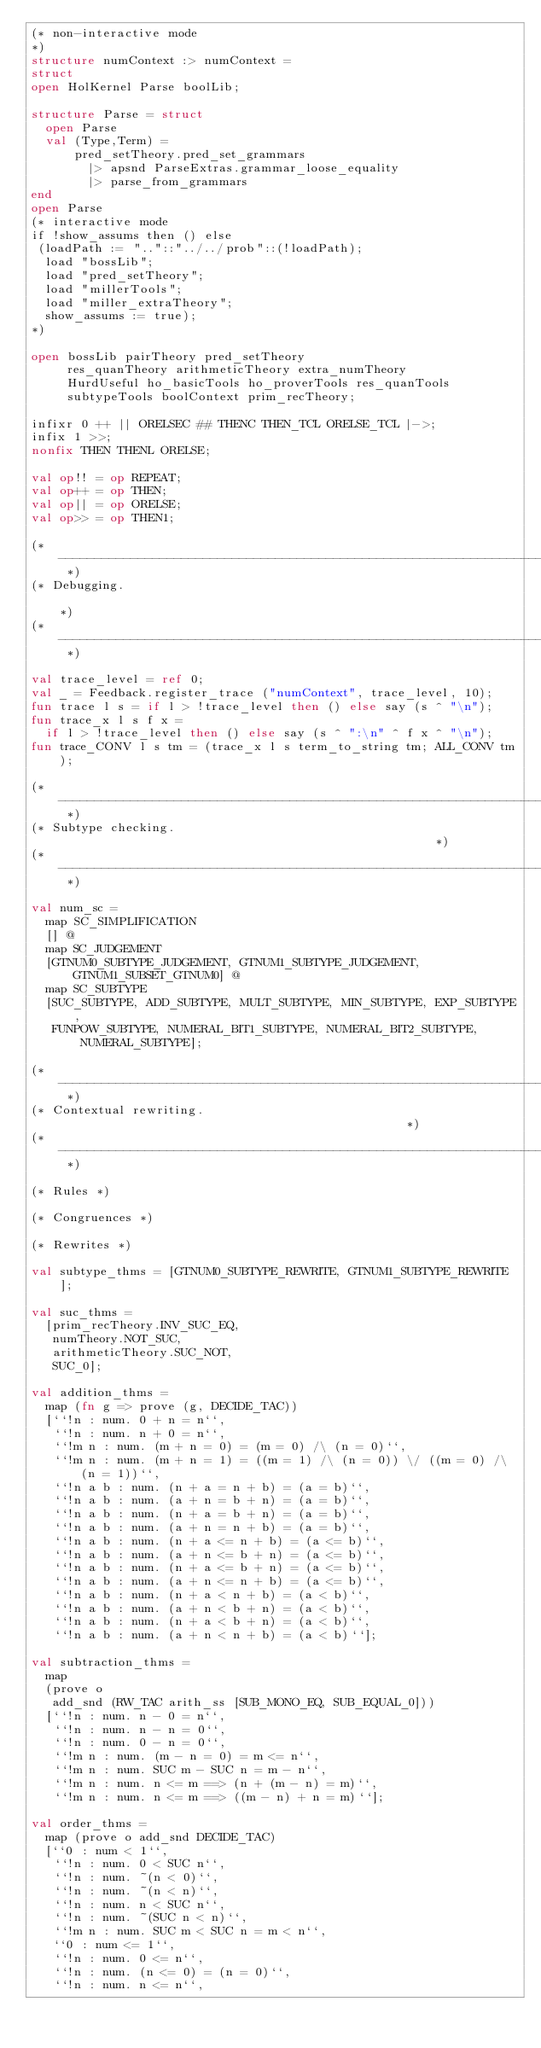<code> <loc_0><loc_0><loc_500><loc_500><_SML_>(* non-interactive mode
*)
structure numContext :> numContext =
struct
open HolKernel Parse boolLib;

structure Parse = struct
  open Parse
  val (Type,Term) =
      pred_setTheory.pred_set_grammars
        |> apsnd ParseExtras.grammar_loose_equality
        |> parse_from_grammars
end
open Parse
(* interactive mode
if !show_assums then () else
 (loadPath := ".."::"../../prob"::(!loadPath);
  load "bossLib";
  load "pred_setTheory";
  load "millerTools";
  load "miller_extraTheory";
  show_assums := true);
*)

open bossLib pairTheory pred_setTheory
     res_quanTheory arithmeticTheory extra_numTheory
     HurdUseful ho_basicTools ho_proverTools res_quanTools
     subtypeTools boolContext prim_recTheory;

infixr 0 ++ || ORELSEC ## THENC THEN_TCL ORELSE_TCL |->;
infix 1 >>;
nonfix THEN THENL ORELSE;

val op!! = op REPEAT;
val op++ = op THEN;
val op|| = op ORELSE;
val op>> = op THEN1;

(* ------------------------------------------------------------------------- *)
(* Debugging.                                                                *)
(* ------------------------------------------------------------------------- *)

val trace_level = ref 0;
val _ = Feedback.register_trace ("numContext", trace_level, 10);
fun trace l s = if l > !trace_level then () else say (s ^ "\n");
fun trace_x l s f x =
  if l > !trace_level then () else say (s ^ ":\n" ^ f x ^ "\n");
fun trace_CONV l s tm = (trace_x l s term_to_string tm; ALL_CONV tm);

(* --------------------------------------------------------------------- *)
(* Subtype checking.                                                     *)
(* --------------------------------------------------------------------- *)

val num_sc =
  map SC_SIMPLIFICATION
  [] @
  map SC_JUDGEMENT
  [GTNUM0_SUBTYPE_JUDGEMENT, GTNUM1_SUBTYPE_JUDGEMENT, GTNUM1_SUBSET_GTNUM0] @
  map SC_SUBTYPE
  [SUC_SUBTYPE, ADD_SUBTYPE, MULT_SUBTYPE, MIN_SUBTYPE, EXP_SUBTYPE,
   FUNPOW_SUBTYPE, NUMERAL_BIT1_SUBTYPE, NUMERAL_BIT2_SUBTYPE, NUMERAL_SUBTYPE];

(* --------------------------------------------------------------------- *)
(* Contextual rewriting.                                                 *)
(* --------------------------------------------------------------------- *)

(* Rules *)

(* Congruences *)

(* Rewrites *)

val subtype_thms = [GTNUM0_SUBTYPE_REWRITE, GTNUM1_SUBTYPE_REWRITE];

val suc_thms =
  [prim_recTheory.INV_SUC_EQ,
   numTheory.NOT_SUC,
   arithmeticTheory.SUC_NOT,
   SUC_0];

val addition_thms =
  map (fn g => prove (g, DECIDE_TAC))
  [``!n : num. 0 + n = n``,
   ``!n : num. n + 0 = n``,
   ``!m n : num. (m + n = 0) = (m = 0) /\ (n = 0)``,
   ``!m n : num. (m + n = 1) = ((m = 1) /\ (n = 0)) \/ ((m = 0) /\ (n = 1))``,
   ``!n a b : num. (n + a = n + b) = (a = b)``,
   ``!n a b : num. (a + n = b + n) = (a = b)``,
   ``!n a b : num. (n + a = b + n) = (a = b)``,
   ``!n a b : num. (a + n = n + b) = (a = b)``,
   ``!n a b : num. (n + a <= n + b) = (a <= b)``,
   ``!n a b : num. (a + n <= b + n) = (a <= b)``,
   ``!n a b : num. (n + a <= b + n) = (a <= b)``,
   ``!n a b : num. (a + n <= n + b) = (a <= b)``,
   ``!n a b : num. (n + a < n + b) = (a < b)``,
   ``!n a b : num. (a + n < b + n) = (a < b)``,
   ``!n a b : num. (n + a < b + n) = (a < b)``,
   ``!n a b : num. (a + n < n + b) = (a < b)``];

val subtraction_thms =
  map
  (prove o
   add_snd (RW_TAC arith_ss [SUB_MONO_EQ, SUB_EQUAL_0]))
  [``!n : num. n - 0 = n``,
   ``!n : num. n - n = 0``,
   ``!n : num. 0 - n = 0``,
   ``!m n : num. (m - n = 0) = m <= n``,
   ``!m n : num. SUC m - SUC n = m - n``,
   ``!m n : num. n <= m ==> (n + (m - n) = m)``,
   ``!m n : num. n <= m ==> ((m - n) + n = m)``];

val order_thms =
  map (prove o add_snd DECIDE_TAC)
  [``0 : num < 1``,
   ``!n : num. 0 < SUC n``,
   ``!n : num. ~(n < 0)``,
   ``!n : num. ~(n < n)``,
   ``!n : num. n < SUC n``,
   ``!n : num. ~(SUC n < n)``,
   ``!m n : num. SUC m < SUC n = m < n``,
   ``0 : num <= 1``,
   ``!n : num. 0 <= n``,
   ``!n : num. (n <= 0) = (n = 0)``,
   ``!n : num. n <= n``,</code> 